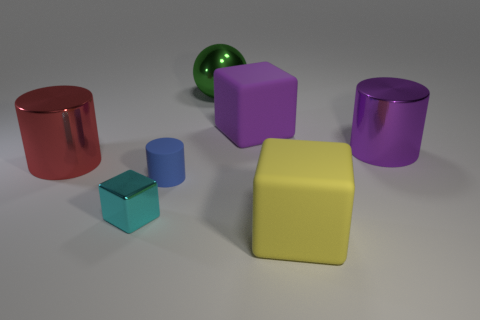Is the red cylinder made of the same material as the green ball?
Keep it short and to the point. Yes. What shape is the large metallic thing right of the yellow matte block?
Your response must be concise. Cylinder. Are there any large red cylinders to the right of the matte object that is in front of the small matte cylinder?
Give a very brief answer. No. Is there another green metal sphere that has the same size as the sphere?
Offer a very short reply. No. The matte cylinder has what size?
Your response must be concise. Small. There is a block to the left of the big cube behind the cyan cube; what size is it?
Your answer should be very brief. Small. What number of spheres are the same color as the small block?
Keep it short and to the point. 0. What number of big purple matte cylinders are there?
Your response must be concise. 0. What number of big blocks are made of the same material as the big purple cylinder?
Keep it short and to the point. 0. What is the size of the rubber thing that is the same shape as the red shiny thing?
Ensure brevity in your answer.  Small. 